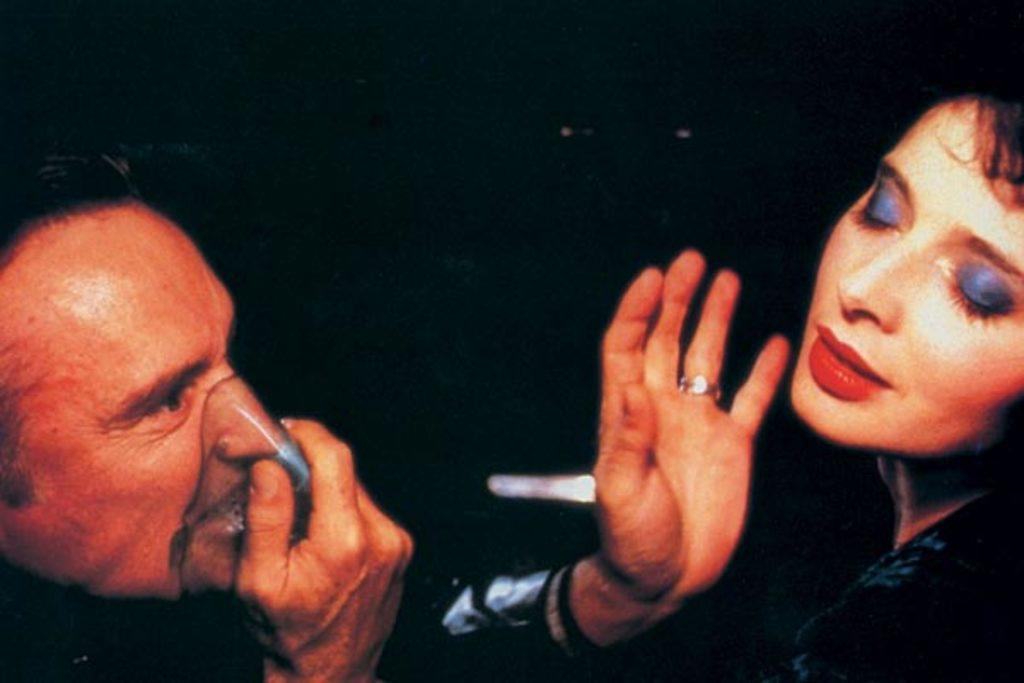How many people are in the image? There are two people in the image. What can be observed about the background of the image? The background of the image is dark. What type of twig is being used as a memory aid by one of the people in the image? There is no twig or memory aid visible in the image; it only features two people and a dark background. 